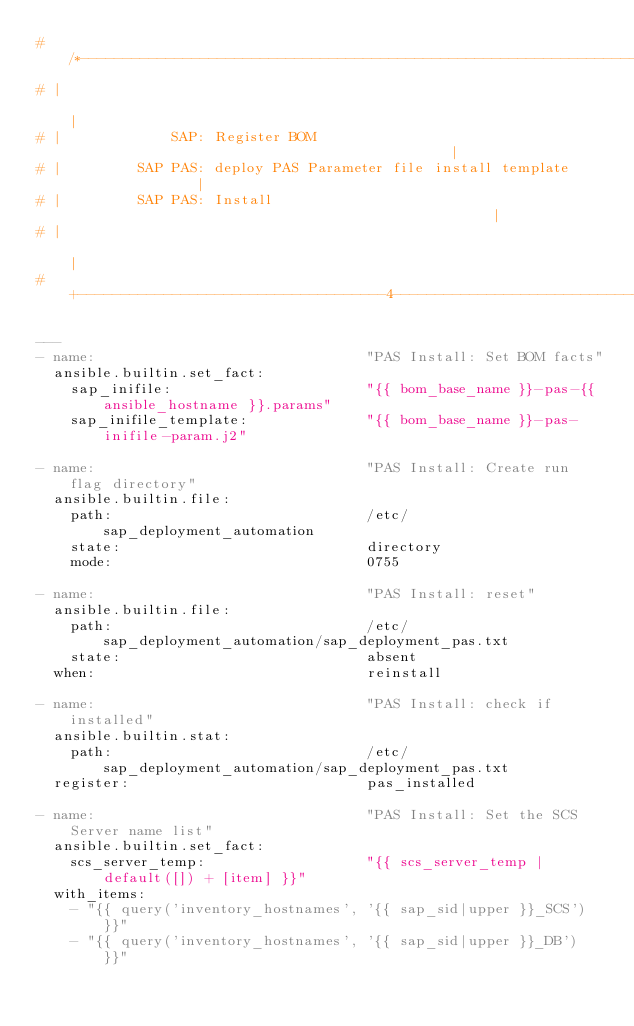Convert code to text. <code><loc_0><loc_0><loc_500><loc_500><_YAML_># /*---------------------------------------------------------------------------8
# |                                                                            |
# |             SAP: Register BOM                                              |
# |         SAP PAS: deploy PAS Parameter file install template                |
# |         SAP PAS: Install                                                   |
# |                                                                            |
# +------------------------------------4--------------------------------------*/

---
- name:                                "PAS Install: Set BOM facts"
  ansible.builtin.set_fact:
    sap_inifile:                       "{{ bom_base_name }}-pas-{{ ansible_hostname }}.params"
    sap_inifile_template:              "{{ bom_base_name }}-pas-inifile-param.j2"

- name:                                "PAS Install: Create run flag directory"
  ansible.builtin.file:
    path:                              /etc/sap_deployment_automation
    state:                             directory
    mode:                              0755

- name:                                "PAS Install: reset"
  ansible.builtin.file:
    path:                              /etc/sap_deployment_automation/sap_deployment_pas.txt
    state:                             absent
  when:                                reinstall

- name:                                "PAS Install: check if installed"
  ansible.builtin.stat:
    path:                              /etc/sap_deployment_automation/sap_deployment_pas.txt
  register:                            pas_installed

- name:                                "PAS Install: Set the SCS Server name list"
  ansible.builtin.set_fact:
    scs_server_temp:                   "{{ scs_server_temp | default([]) + [item] }}"
  with_items:
    - "{{ query('inventory_hostnames', '{{ sap_sid|upper }}_SCS') }}"
    - "{{ query('inventory_hostnames', '{{ sap_sid|upper }}_DB') }}"
</code> 